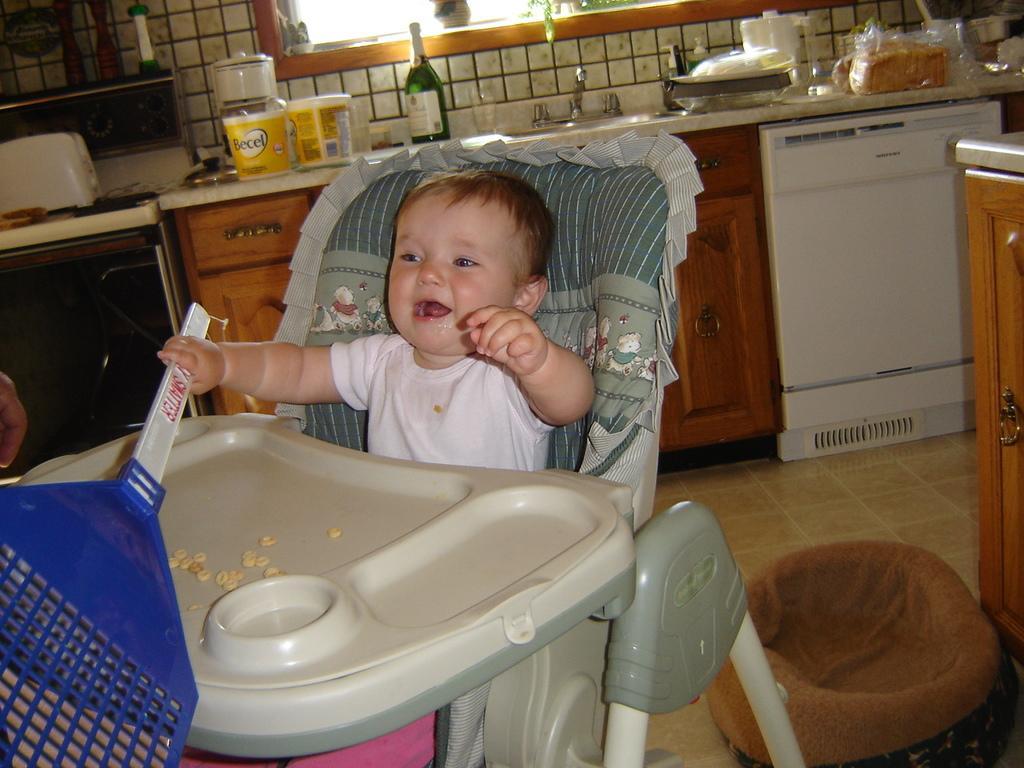In one or two sentences, can you explain what this image depicts? Here a kid is sitting on the stroller and holding a bat in his hand. In the background there are cupboards,grinder,wine bottle,sink,bread,jug,window and this is the floor. 